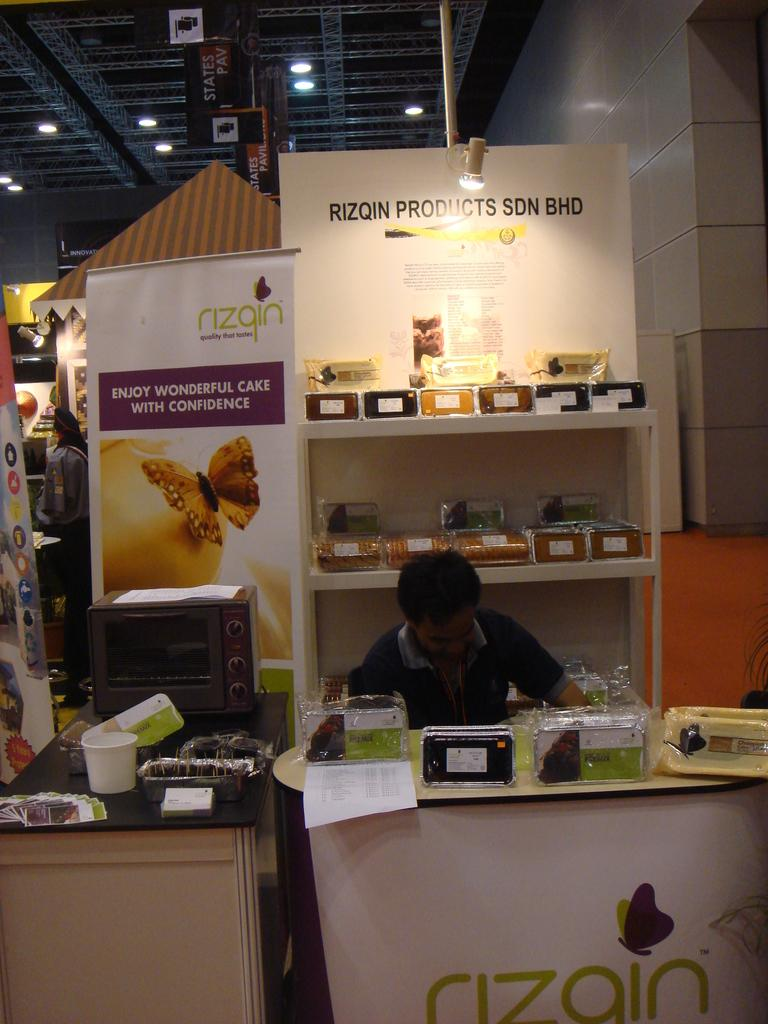Provide a one-sentence caption for the provided image. a store display of Rizqin Products SDN BHD. 